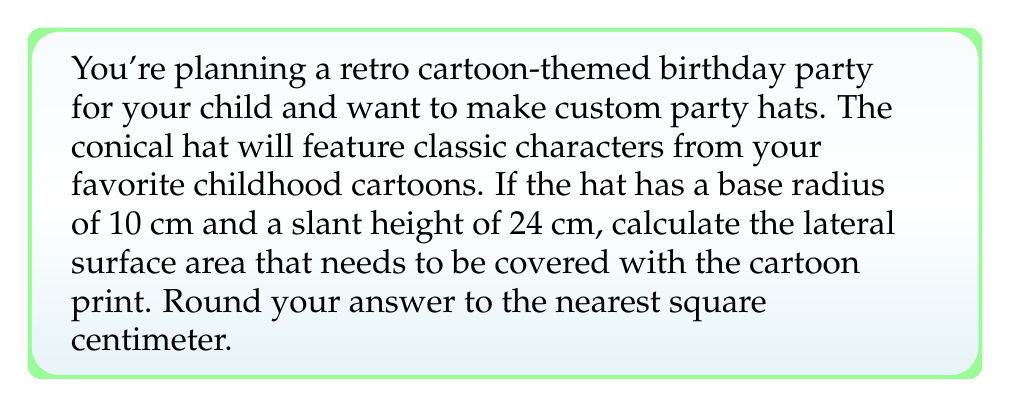Help me with this question. Let's approach this step-by-step:

1) The lateral surface area of a cone is given by the formula:

   $$A = \pi r s$$

   Where $A$ is the lateral surface area, $r$ is the radius of the base, and $s$ is the slant height.

2) We're given:
   - Base radius $(r) = 10$ cm
   - Slant height $(s) = 24$ cm

3) Let's substitute these values into our formula:

   $$A = \pi \cdot 10 \cdot 24$$

4) Simplify:
   $$A = 240\pi$$

5) Now, let's calculate this value:
   $$A \approx 753.98 \text{ cm}^2$$

6) Rounding to the nearest square centimeter:
   $$A \approx 754 \text{ cm}^2$$

[asy]
import geometry;

size(200);

pair O=(0,0), A=(3,0), B=(0,4);
draw(O--A--B--O);
draw(Arc(O,A,180), dashed);
label("10 cm",O--A,S);
label("24 cm",A--B,NE);
label("r",O--A/2,N);
label("s",A--B/2,SE);

[/asy]

This diagram illustrates the cone's cross-section, showing the base radius and slant height.
Answer: The lateral surface area of the conical party hat is approximately 754 cm². 